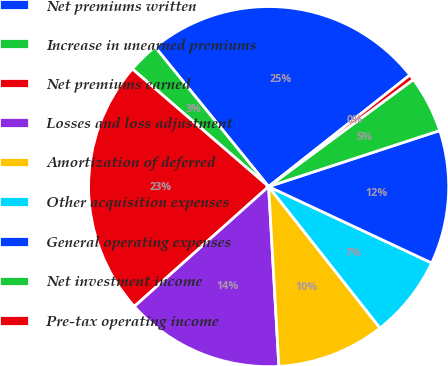<chart> <loc_0><loc_0><loc_500><loc_500><pie_chart><fcel>Net premiums written<fcel>Increase in unearned premiums<fcel>Net premiums earned<fcel>Losses and loss adjustment<fcel>Amortization of deferred<fcel>Other acquisition expenses<fcel>General operating expenses<fcel>Net investment income<fcel>Pre-tax operating income<nl><fcel>25.23%<fcel>2.8%<fcel>22.93%<fcel>14.31%<fcel>9.71%<fcel>7.41%<fcel>12.01%<fcel>5.1%<fcel>0.5%<nl></chart> 